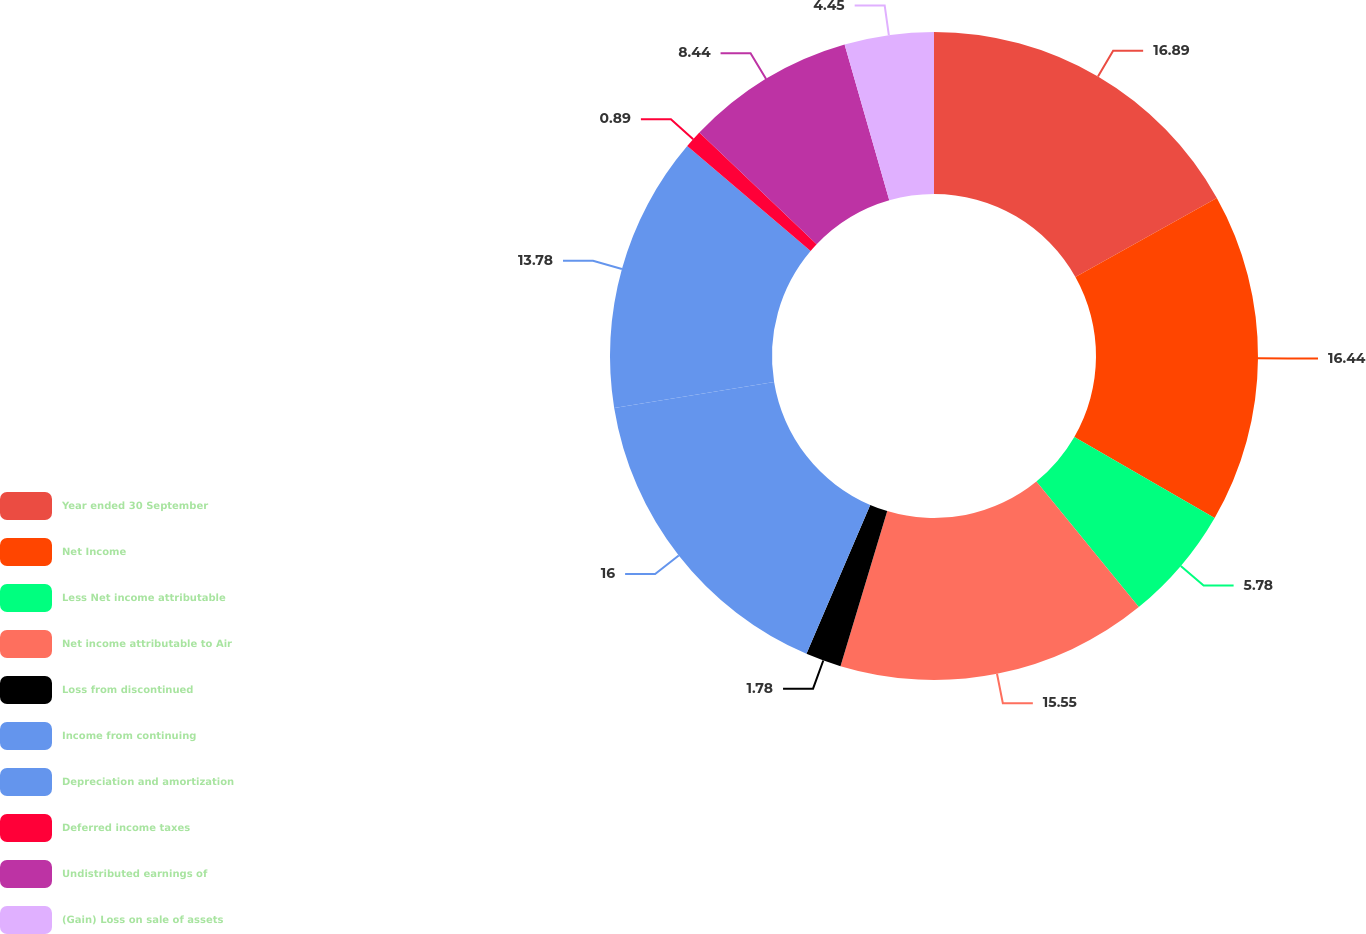Convert chart. <chart><loc_0><loc_0><loc_500><loc_500><pie_chart><fcel>Year ended 30 September<fcel>Net Income<fcel>Less Net income attributable<fcel>Net income attributable to Air<fcel>Loss from discontinued<fcel>Income from continuing<fcel>Depreciation and amortization<fcel>Deferred income taxes<fcel>Undistributed earnings of<fcel>(Gain) Loss on sale of assets<nl><fcel>16.89%<fcel>16.44%<fcel>5.78%<fcel>15.55%<fcel>1.78%<fcel>16.0%<fcel>13.78%<fcel>0.89%<fcel>8.44%<fcel>4.45%<nl></chart> 